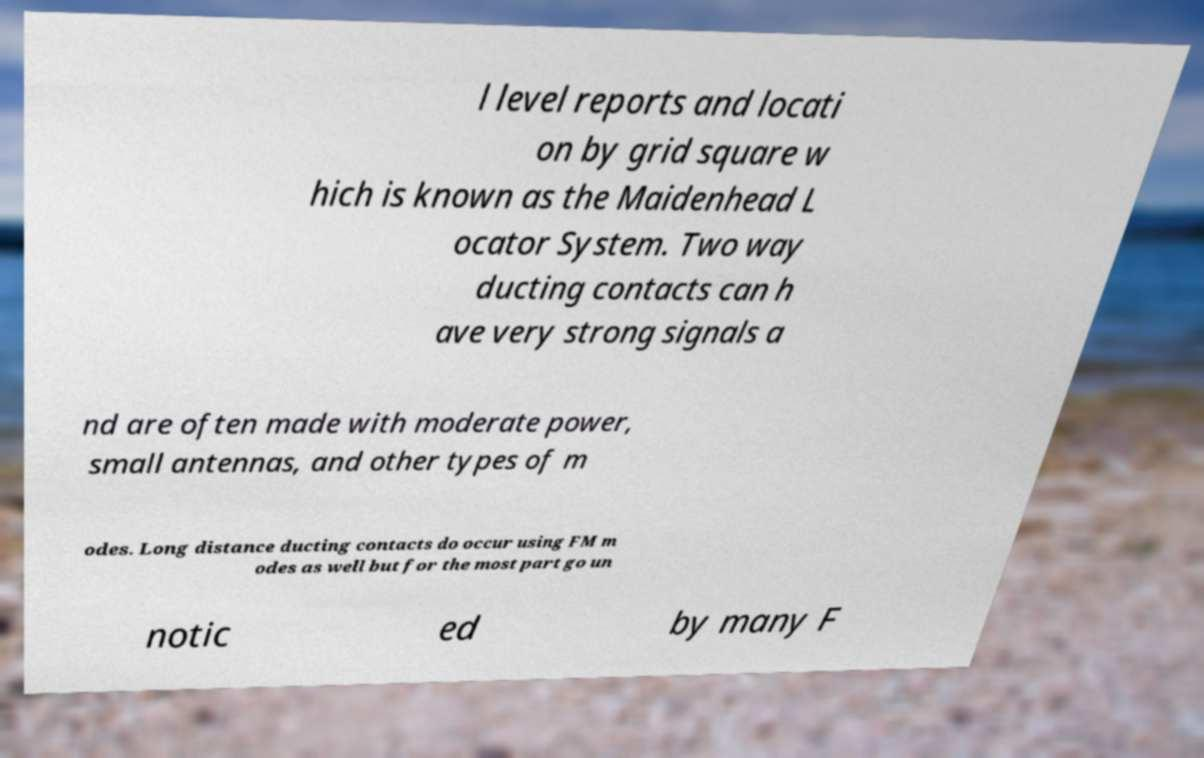Could you extract and type out the text from this image? l level reports and locati on by grid square w hich is known as the Maidenhead L ocator System. Two way ducting contacts can h ave very strong signals a nd are often made with moderate power, small antennas, and other types of m odes. Long distance ducting contacts do occur using FM m odes as well but for the most part go un notic ed by many F 